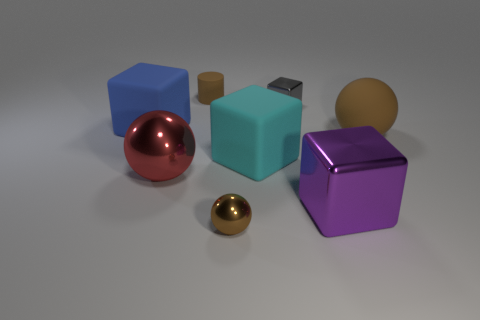There is a matte ball; does it have the same color as the ball that is in front of the purple cube?
Provide a short and direct response. Yes. Is the big brown thing made of the same material as the tiny thing that is behind the gray metal object?
Give a very brief answer. Yes. What is the color of the large metallic object right of the big shiny ball?
Your response must be concise. Purple. Is there a block left of the small brown object that is left of the small brown ball?
Keep it short and to the point. Yes. Do the large rubber block that is to the right of the blue matte cube and the matte thing behind the large blue matte cube have the same color?
Keep it short and to the point. No. How many objects are behind the purple metallic cube?
Give a very brief answer. 6. How many objects are the same color as the small cylinder?
Offer a terse response. 2. Are the block behind the blue rubber block and the large brown thing made of the same material?
Provide a short and direct response. No. How many other objects are made of the same material as the blue object?
Provide a succinct answer. 3. Is the number of small shiny objects that are in front of the purple thing greater than the number of small yellow shiny cubes?
Keep it short and to the point. Yes. 